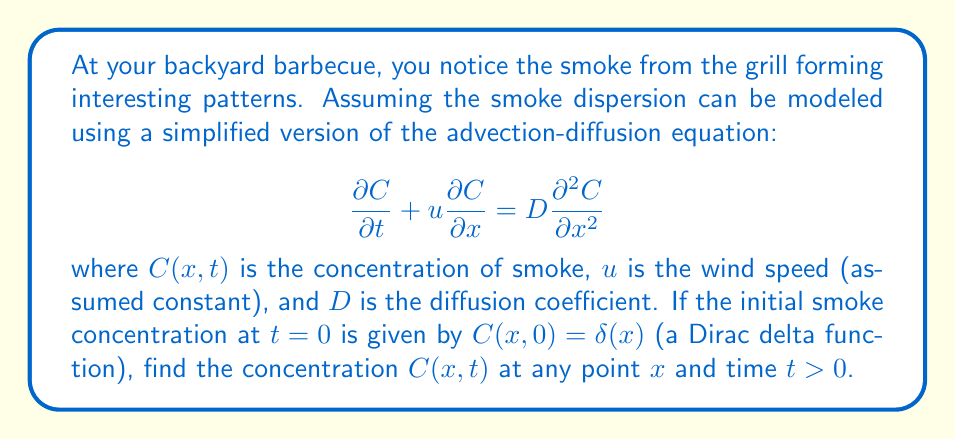Solve this math problem. To solve this problem, we'll follow these steps:

1) The given equation is a linear partial differential equation (PDE) known as the advection-diffusion equation. For the given initial condition (a point source), we can solve this using the method of Fourier transforms.

2) Let's denote the Fourier transform of $C(x,t)$ as $\hat{C}(k,t)$. Taking the Fourier transform of both sides of the equation:

   $$\frac{\partial \hat{C}}{\partial t} + iuk\hat{C} = -Dk^2\hat{C}$$

3) This is now an ordinary differential equation in $t$:

   $$\frac{\partial \hat{C}}{\partial t} = -(iuk + Dk^2)\hat{C}$$

4) The solution to this ODE is:

   $$\hat{C}(k,t) = \hat{C}(k,0)e^{-(iuk + Dk^2)t}$$

5) The Fourier transform of the initial condition $\delta(x)$ is 1, so:

   $$\hat{C}(k,t) = e^{-(iuk + Dk^2)t}$$

6) To get $C(x,t)$, we need to take the inverse Fourier transform:

   $$C(x,t) = \frac{1}{2\pi}\int_{-\infty}^{\infty} e^{ikx}e^{-(iuk + Dk^2)t}dk$$

7) This integral can be evaluated using the method of completing the square:

   $$C(x,t) = \frac{1}{2\pi}\int_{-\infty}^{\infty} e^{ikx-iukt-Dk^2t}dk
   = \frac{1}{2\pi}\int_{-\infty}^{\infty} e^{-D(k^2t + \frac{2i(x-ut)k}{2D})}dk$$

8) Completing the square in the exponent:

   $$C(x,t) = \frac{1}{2\pi}e^{-\frac{(x-ut)^2}{4Dt}}\int_{-\infty}^{\infty} e^{-Dt(k + \frac{i(x-ut)}{2Dt})^2}dk$$

9) This integral evaluates to $\sqrt{\frac{\pi}{Dt}}$, giving us the final solution:

   $$C(x,t) = \frac{1}{\sqrt{4\pi Dt}}e^{-\frac{(x-ut)^2}{4Dt}}$$

This is the fundamental solution to the advection-diffusion equation, also known as the Green's function.
Answer: $$C(x,t) = \frac{1}{\sqrt{4\pi Dt}}e^{-\frac{(x-ut)^2}{4Dt}}$$ 